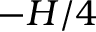Convert formula to latex. <formula><loc_0><loc_0><loc_500><loc_500>- H / 4</formula> 